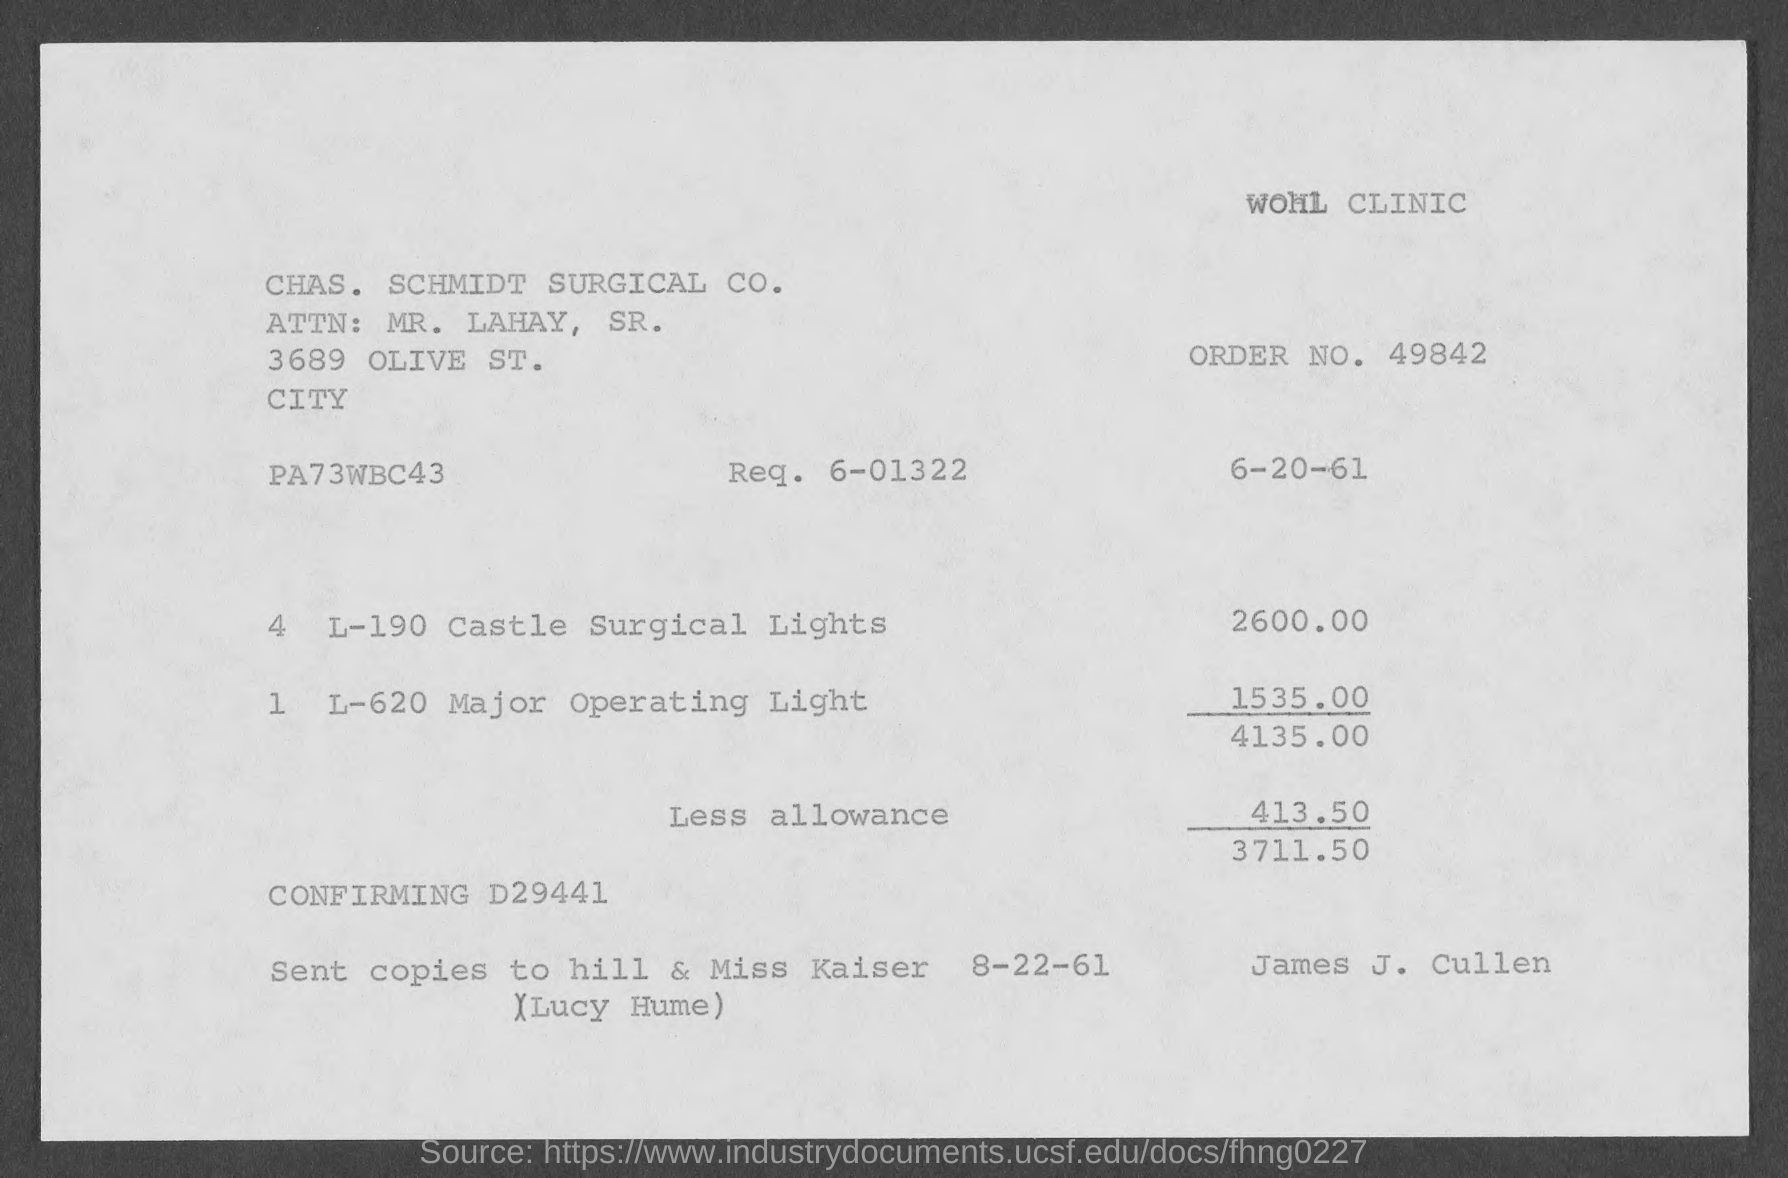What details can you provide about the sender and recipient of this invoice? The invoice is from the CHAS. SCHMIDT SURGICAL CO. to WOHL CLINIC. Attention is given to a Mr. Lahay, Sr., located at 3689 Olive St. City. The order number is 49842, with an additional reference number PA73WBC43 and confirmation number D29441. 